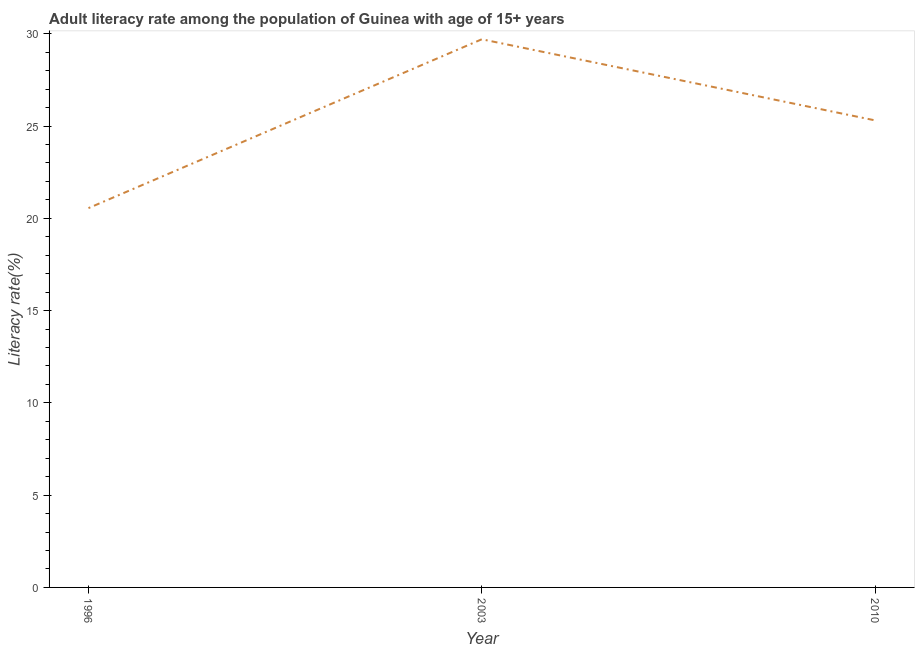What is the adult literacy rate in 2010?
Your response must be concise. 25.31. Across all years, what is the maximum adult literacy rate?
Your response must be concise. 29.7. Across all years, what is the minimum adult literacy rate?
Provide a short and direct response. 20.55. In which year was the adult literacy rate maximum?
Your answer should be compact. 2003. In which year was the adult literacy rate minimum?
Your answer should be compact. 1996. What is the sum of the adult literacy rate?
Ensure brevity in your answer.  75.57. What is the difference between the adult literacy rate in 1996 and 2003?
Make the answer very short. -9.15. What is the average adult literacy rate per year?
Your answer should be compact. 25.19. What is the median adult literacy rate?
Give a very brief answer. 25.31. In how many years, is the adult literacy rate greater than 17 %?
Your answer should be compact. 3. What is the ratio of the adult literacy rate in 1996 to that in 2003?
Give a very brief answer. 0.69. Is the adult literacy rate in 2003 less than that in 2010?
Keep it short and to the point. No. What is the difference between the highest and the second highest adult literacy rate?
Offer a very short reply. 4.4. What is the difference between the highest and the lowest adult literacy rate?
Provide a succinct answer. 9.15. Does the adult literacy rate monotonically increase over the years?
Make the answer very short. No. How many lines are there?
Offer a very short reply. 1. Are the values on the major ticks of Y-axis written in scientific E-notation?
Ensure brevity in your answer.  No. What is the title of the graph?
Your answer should be very brief. Adult literacy rate among the population of Guinea with age of 15+ years. What is the label or title of the X-axis?
Provide a short and direct response. Year. What is the label or title of the Y-axis?
Your answer should be very brief. Literacy rate(%). What is the Literacy rate(%) in 1996?
Provide a succinct answer. 20.55. What is the Literacy rate(%) of 2003?
Keep it short and to the point. 29.7. What is the Literacy rate(%) of 2010?
Offer a terse response. 25.31. What is the difference between the Literacy rate(%) in 1996 and 2003?
Provide a succinct answer. -9.15. What is the difference between the Literacy rate(%) in 1996 and 2010?
Provide a short and direct response. -4.75. What is the difference between the Literacy rate(%) in 2003 and 2010?
Ensure brevity in your answer.  4.4. What is the ratio of the Literacy rate(%) in 1996 to that in 2003?
Your answer should be compact. 0.69. What is the ratio of the Literacy rate(%) in 1996 to that in 2010?
Offer a very short reply. 0.81. What is the ratio of the Literacy rate(%) in 2003 to that in 2010?
Keep it short and to the point. 1.17. 